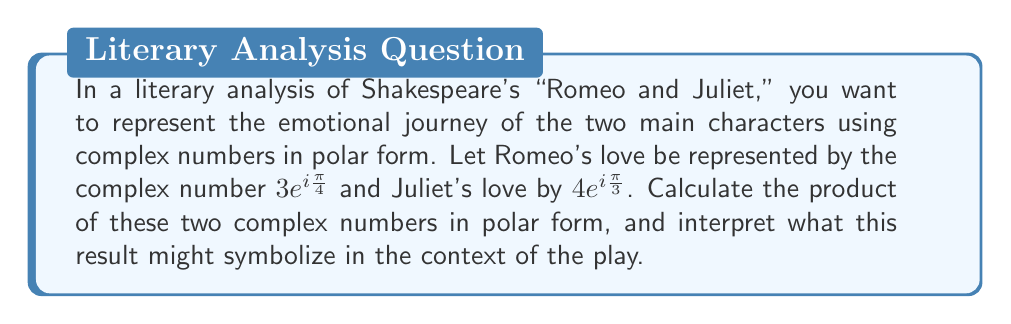Show me your answer to this math problem. To solve this problem, we'll follow these steps:

1) Recall the formula for multiplying complex numbers in polar form:
   $$(r_1e^{i\theta_1})(r_2e^{i\theta_2}) = r_1r_2e^{i(\theta_1+\theta_2)}$$

2) In our case:
   Romeo's love: $r_1 = 3$, $\theta_1 = \frac{\pi}{4}$
   Juliet's love: $r_2 = 4$, $\theta_2 = \frac{\pi}{3}$

3) Multiply the magnitudes:
   $r_1r_2 = 3 \cdot 4 = 12$

4) Add the angles:
   $\theta_1 + \theta_2 = \frac{\pi}{4} + \frac{\pi}{3} = \frac{3\pi}{12} + \frac{4\pi}{12} = \frac{7\pi}{12}$

5) Combine the results into polar form:
   $12e^{i\frac{7\pi}{12}}$

Interpretation: The resulting complex number represents the combined effect of Romeo and Juliet's love. The magnitude (12) is larger than either of the individual magnitudes, suggesting that their love together is stronger than either alone. The angle ($\frac{7\pi}{12}$) is between their individual angles, possibly symbolizing a middle ground or compromise between their perspectives. This could represent how their love brings them together despite their families' feud.
Answer: $12e^{i\frac{7\pi}{12}}$ 